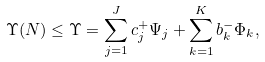<formula> <loc_0><loc_0><loc_500><loc_500>\Upsilon ( N ) \leq \Upsilon = \sum _ { j = 1 } ^ { J } c _ { j } ^ { + } \Psi _ { j } + \sum _ { k = 1 } ^ { K } b _ { k } ^ { - } \Phi _ { k } ,</formula> 